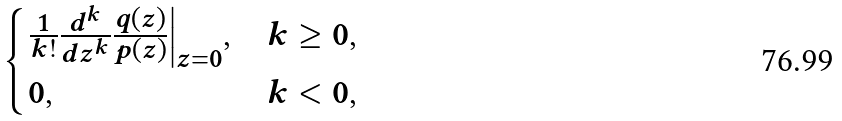<formula> <loc_0><loc_0><loc_500><loc_500>\begin{cases} \frac { 1 } { k ! } \frac { d ^ { k } } { d z ^ { k } } \frac { q ( z ) } { p ( z ) } \Big | _ { z = 0 } , & k \geq 0 , \\ 0 , & k < 0 , \end{cases}</formula> 